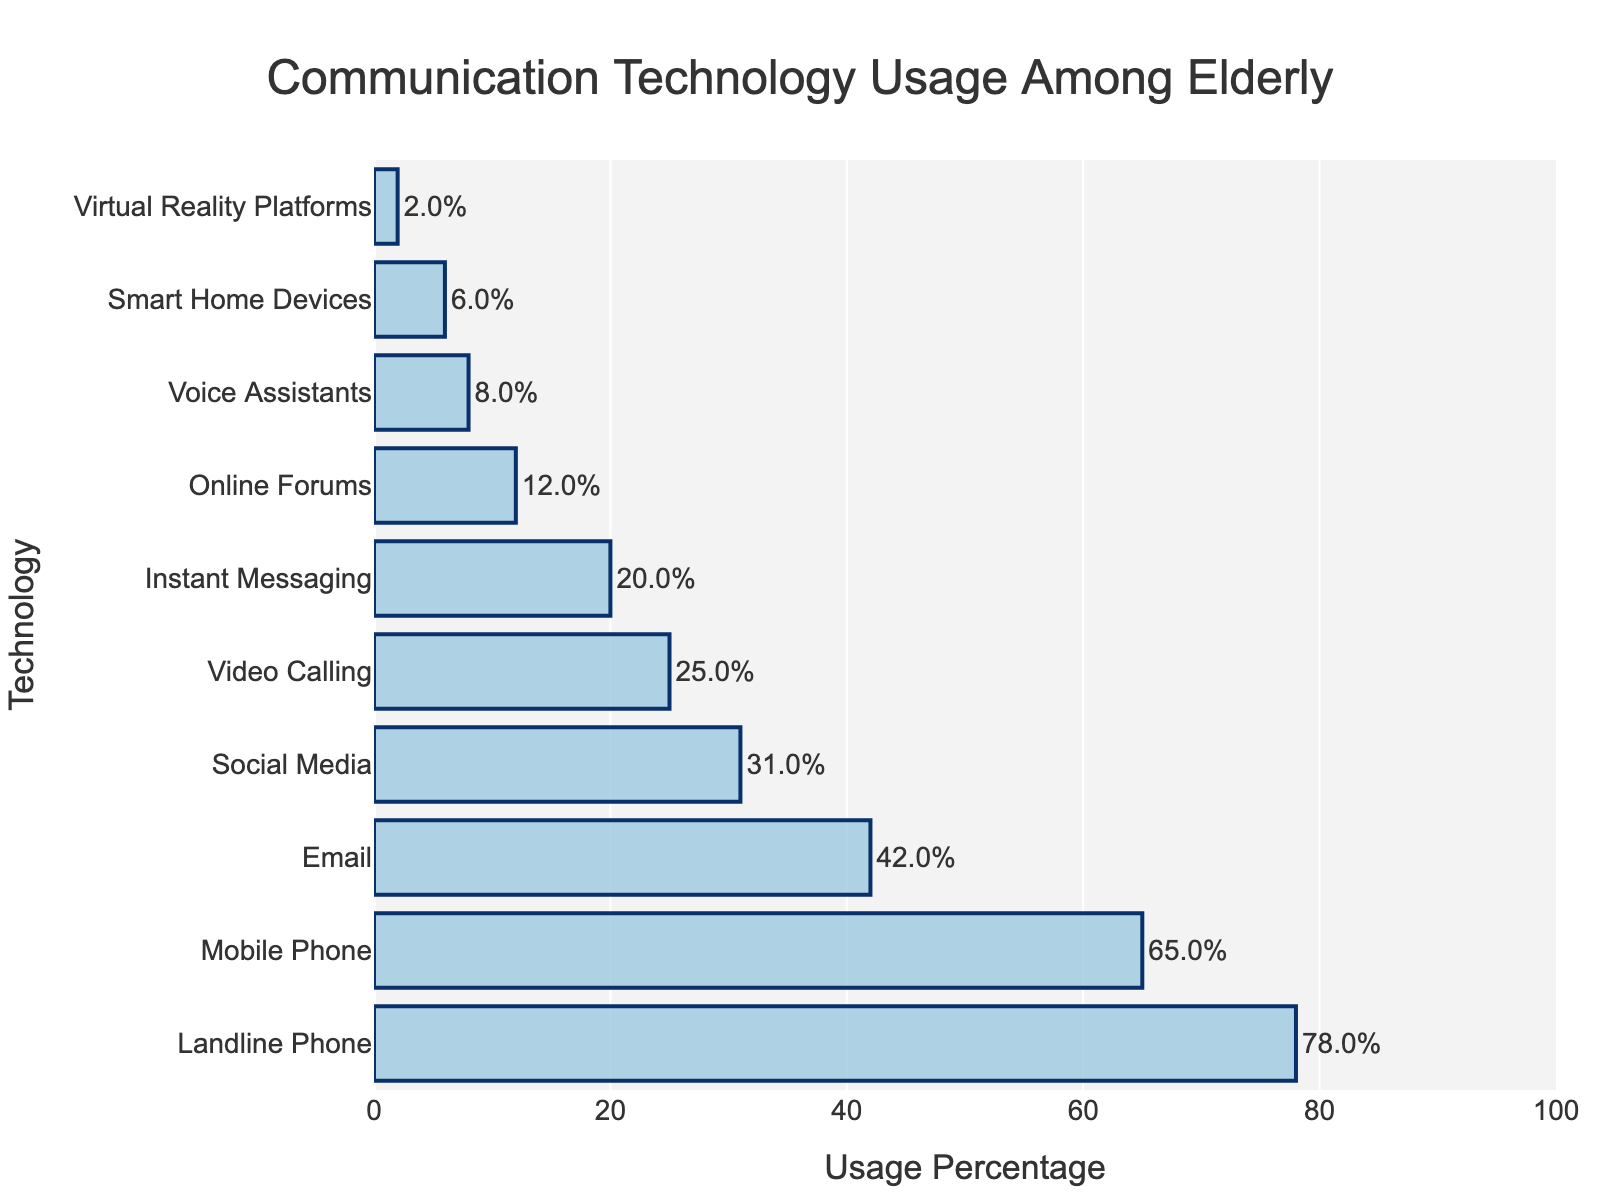Which technology has the highest usage percentage? The bar chart shows the usage percentages for different technologies, and the longest bar represents the highest usage.
Answer: Landline Phone How much more popular is the Landline Phone compared to Email? The usage percentage for Landline Phone is 78%, and for Email, it's 42%. The difference is 78 - 42 = 36%.
Answer: 36% What is the combined usage percentage of Social Media and Video Calling? The usage percentage for Social Media is 31%, and for Video Calling, it's 25%. The combined percentage is 31 + 25 = 56%.
Answer: 56% Which technology has a usage percentage less than 10%? By looking at the bars with usage percentages smaller than 10%, it's clear that Voice Assistants, Smart Home Devices, and Virtual Reality Platforms fall under this category (8%, 6%, and 2% respectively).
Answer: Voice Assistants, Smart Home Devices, Virtual Reality Platforms How much lower is the usage percentage of Instant Messaging compared to Mobile Phone? The usage for Mobile Phone is 65% and for Instant Messaging, it's 20%. The difference is 65 - 20 = 45%.
Answer: 45% What is the median usage percentage of the listed technologies? There are ten technologies, so the median will be the average of the 5th and 6th highest percentages. The 5th and 6th highest are Social Media (31%) and Video Calling (25%), respectively, so the median is (31 + 25) / 2 = 28%.
Answer: 28% Compare the usage of Online Forums to Voice Assistants. Which one is more popular and by how much? The usage percentage for Online Forums is 12%, and for Voice Assistants, it is 8%. Online Forums are more popular by 12 - 8 = 4%.
Answer: Online Forums by 4% What is the average usage percentage of all technologies? Sum all percentages: 78 + 65 + 42 + 31 + 25 + 20 + 12 + 8 + 6 + 2 = 289. There are 10 technologies, so the average is 289 / 10 = 28.9%.
Answer: 28.9% What percentage of elderly population uses technologies with more than 50% usage? Only Landline Phone (78%) and Mobile Phone (65%) have usage percentages more than 50%. Add these percentages: 78 + 65 = 143%.
Answer: 143% 